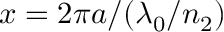Convert formula to latex. <formula><loc_0><loc_0><loc_500><loc_500>x = 2 \pi a / ( \lambda _ { 0 } / n _ { 2 } )</formula> 